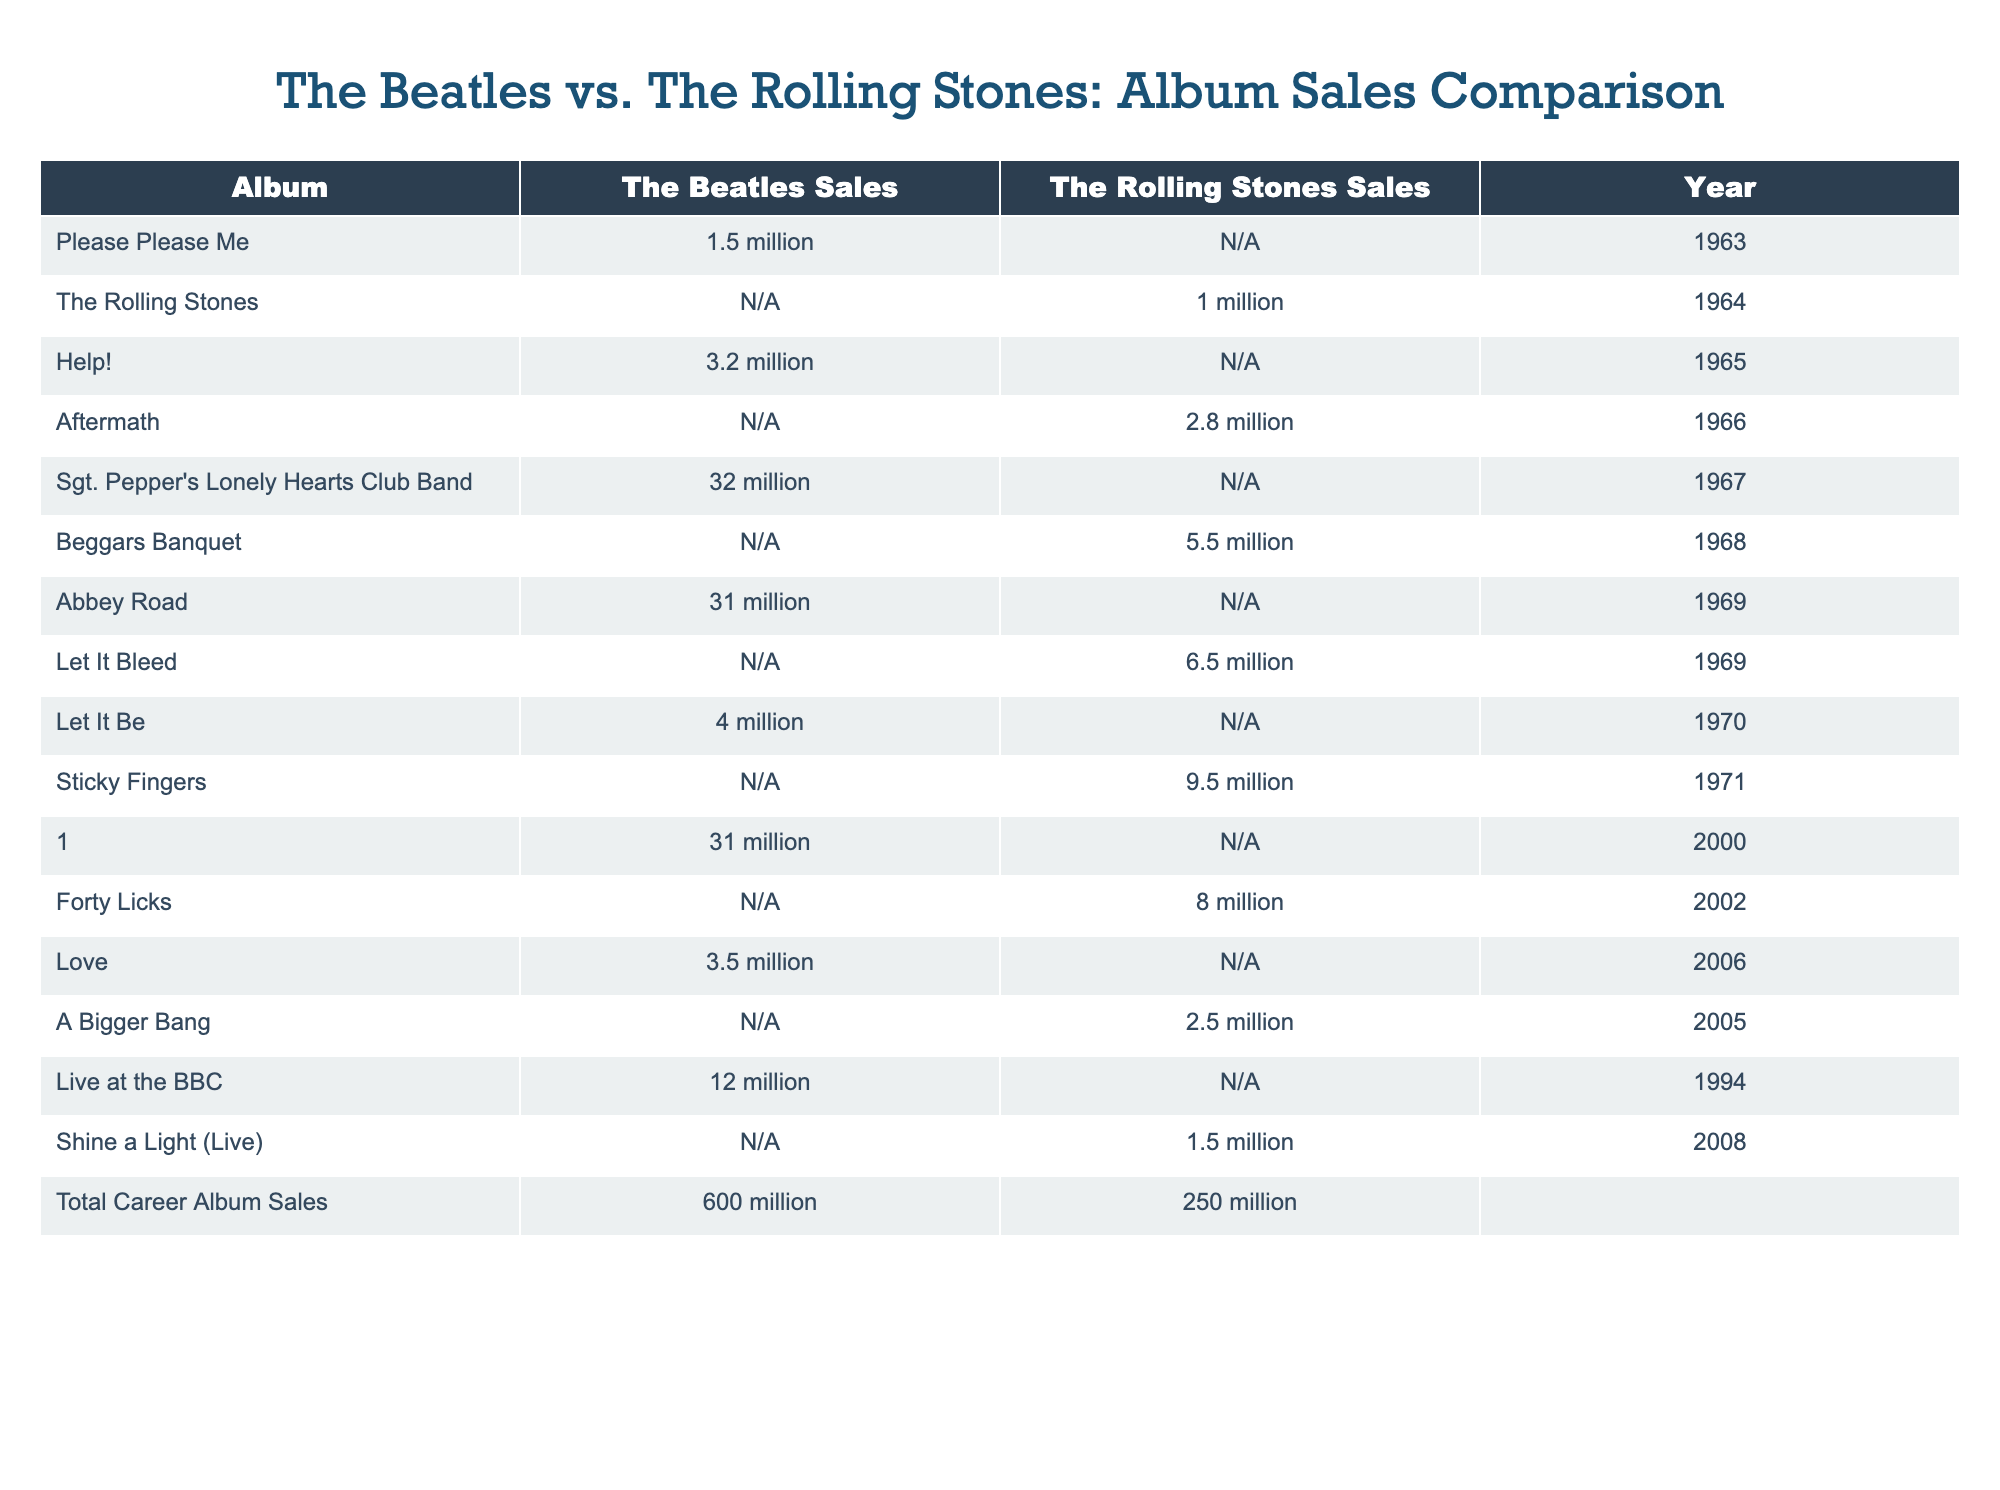What is the total career album sales for The Beatles? The table shows the total career album sales for The Beatles as 600 million.
Answer: 600 million What is the year of release for "Abbey Road"? The table lists "Abbey Road" as released in 1969.
Answer: 1969 Did The Rolling Stones have any album sales in 1963? The table indicates that The Rolling Stones did not have album sales recorded in 1963, as their first listed album sales start from 1964.
Answer: No Which album had the highest sales for The Beatles? According to the table, "Sgt. Pepper's Lonely Hearts Club Band" had the highest sales for The Beatles at 32 million.
Answer: 32 million What is the difference in total career album sales between The Beatles and The Rolling Stones? The total career album sales for The Beatles is 600 million and for The Rolling Stones is 250 million. The difference is 600 million - 250 million = 350 million.
Answer: 350 million Which album had higher sales: "Help!" by The Beatles or "Let It Bleed" by The Rolling Stones? "Help!" sold 3.2 million, while "Let It Bleed" sold 6.5 million. Since 6.5 million > 3.2 million, "Let It Bleed" had higher sales.
Answer: Let It Bleed How many albums did The Beatles sell over 30 million? The table shows two albums with sales over 30 million: "Sgt. Pepper's Lonely Hearts Club Band" and "Abbey Road." Therefore, there are 2 albums.
Answer: 2 albums What is the total sales of albums released between 1965 to 1971 for The Beatles? The relevant albums in this period are "Help!" (3.2 million), "Sgt. Pepper's Lonely Hearts Club Band" (32 million), "Abbey Road" (31 million), and "Let It Be" (4 million). The total sales from these albums is 3.2 million + 32 million + 31 million + 4 million = 70.2 million.
Answer: 70.2 million Were any albums released in 2006 by The Beatles? The table lists "Love" with sales of 3.5 million as an album released in 2006 by The Beatles, indicating there was an album released that year.
Answer: Yes 